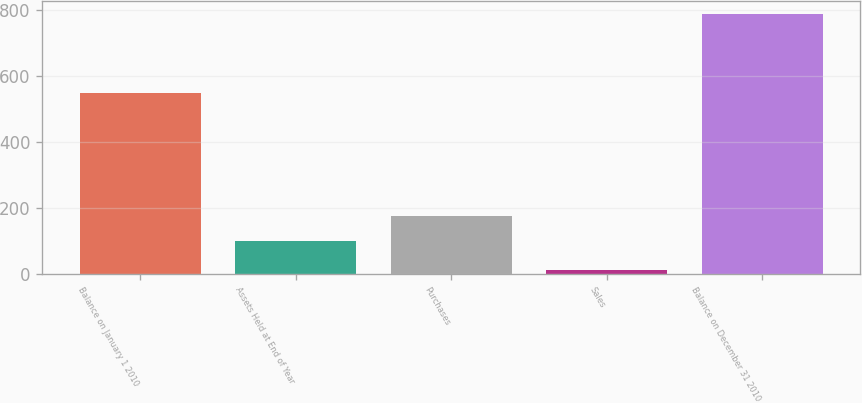Convert chart to OTSL. <chart><loc_0><loc_0><loc_500><loc_500><bar_chart><fcel>Balance on January 1 2010<fcel>Assets Held at End of Year<fcel>Purchases<fcel>Sales<fcel>Balance on December 31 2010<nl><fcel>550<fcel>100<fcel>177.6<fcel>13<fcel>789<nl></chart> 